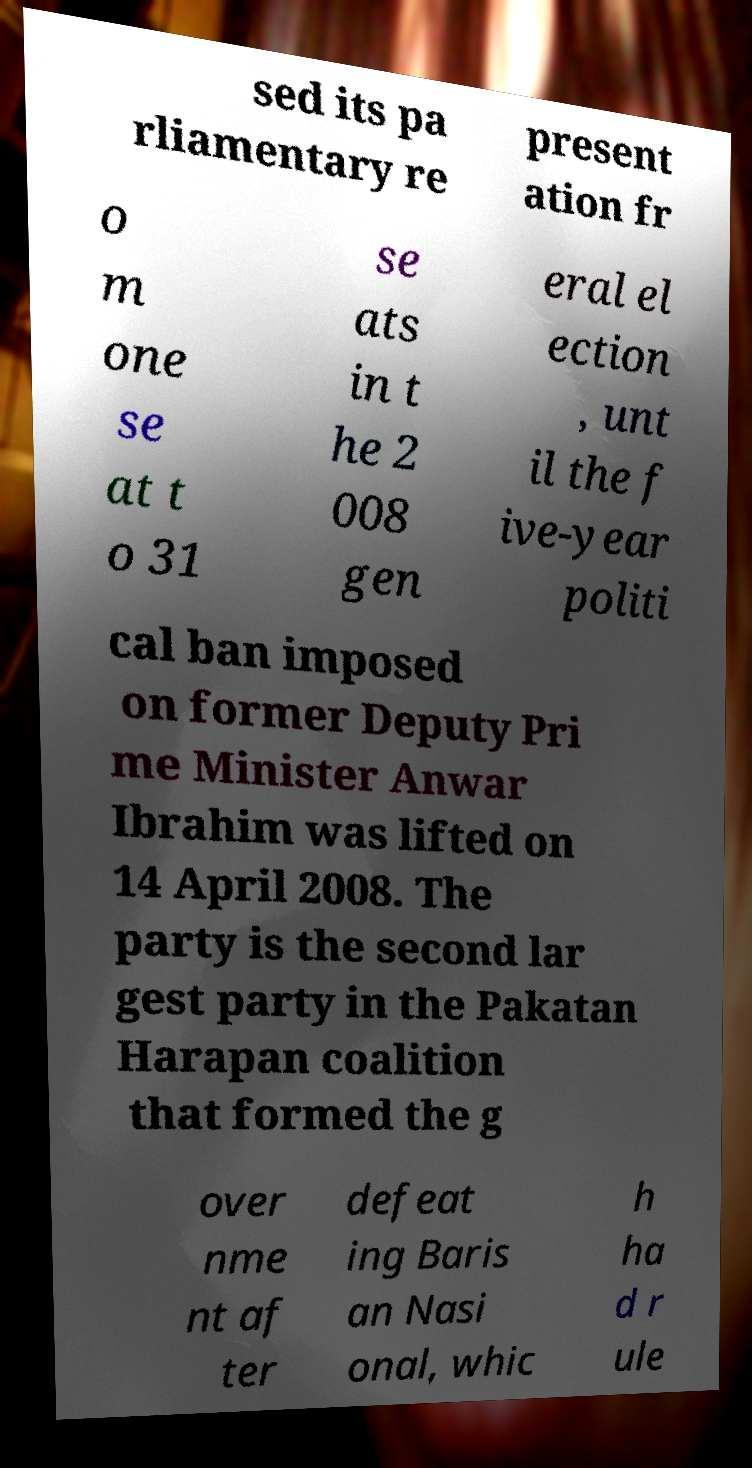There's text embedded in this image that I need extracted. Can you transcribe it verbatim? sed its pa rliamentary re present ation fr o m one se at t o 31 se ats in t he 2 008 gen eral el ection , unt il the f ive-year politi cal ban imposed on former Deputy Pri me Minister Anwar Ibrahim was lifted on 14 April 2008. The party is the second lar gest party in the Pakatan Harapan coalition that formed the g over nme nt af ter defeat ing Baris an Nasi onal, whic h ha d r ule 